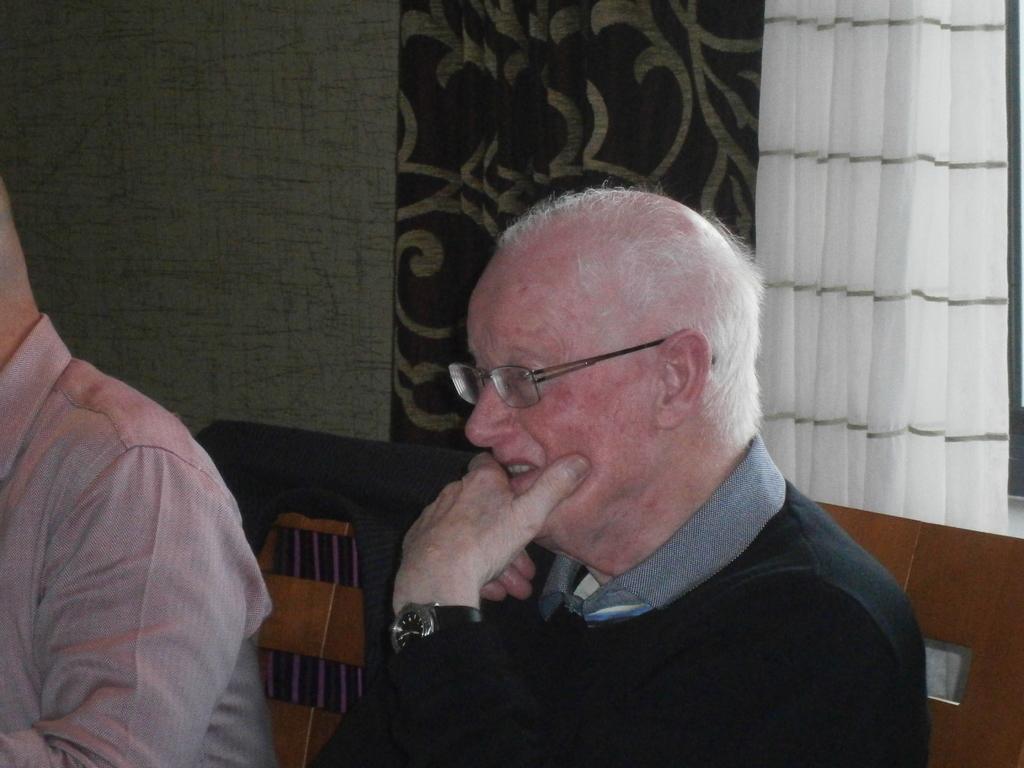Could you give a brief overview of what you see in this image? In this image, we can see people sitting on the chairs and one of them is wearing glasses. In the background, there is a wall and we can see curtains. 